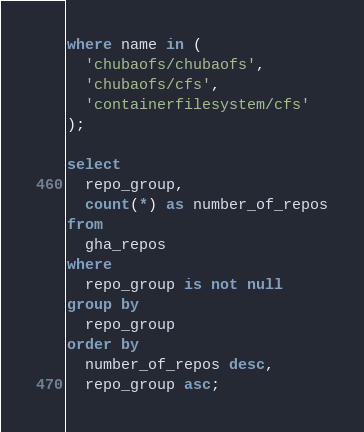Convert code to text. <code><loc_0><loc_0><loc_500><loc_500><_SQL_>where name in (
  'chubaofs/chubaofs',
  'chubaofs/cfs',
  'containerfilesystem/cfs'
);

select
  repo_group,
  count(*) as number_of_repos
from
  gha_repos
where
  repo_group is not null
group by
  repo_group
order by
  number_of_repos desc,
  repo_group asc;
</code> 